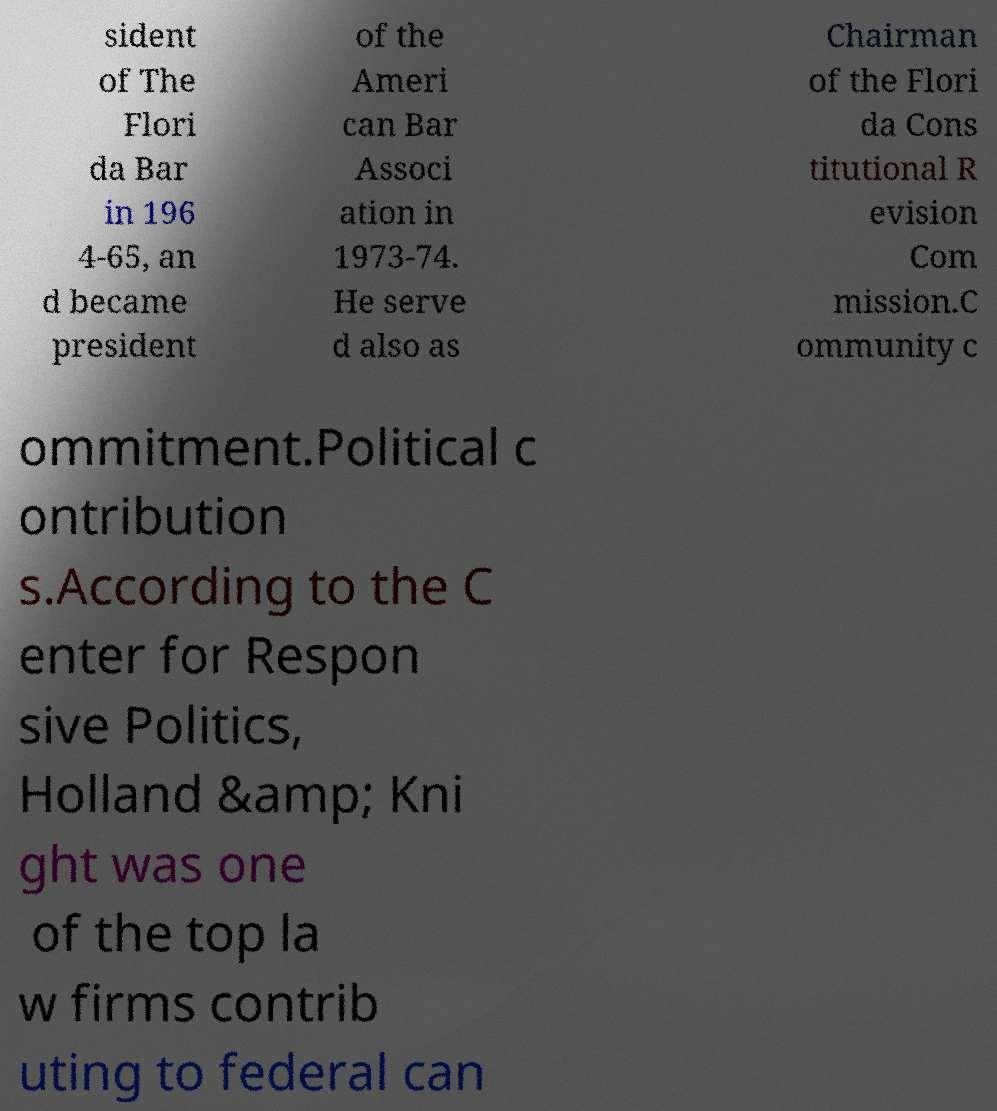Could you assist in decoding the text presented in this image and type it out clearly? sident of The Flori da Bar in 196 4-65, an d became president of the Ameri can Bar Associ ation in 1973-74. He serve d also as Chairman of the Flori da Cons titutional R evision Com mission.C ommunity c ommitment.Political c ontribution s.According to the C enter for Respon sive Politics, Holland &amp; Kni ght was one of the top la w firms contrib uting to federal can 